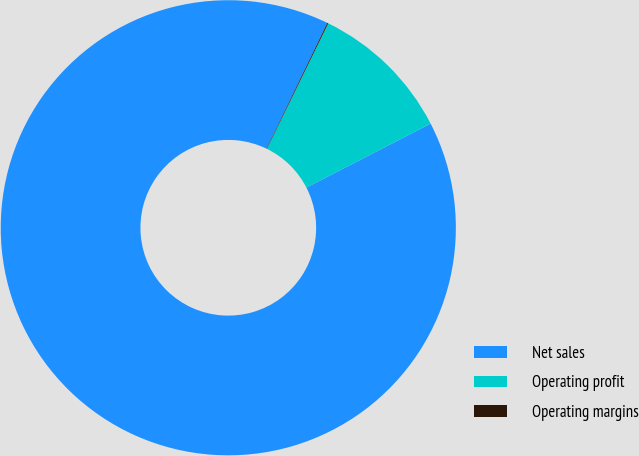Convert chart. <chart><loc_0><loc_0><loc_500><loc_500><pie_chart><fcel>Net sales<fcel>Operating profit<fcel>Operating margins<nl><fcel>89.74%<fcel>10.2%<fcel>0.07%<nl></chart> 